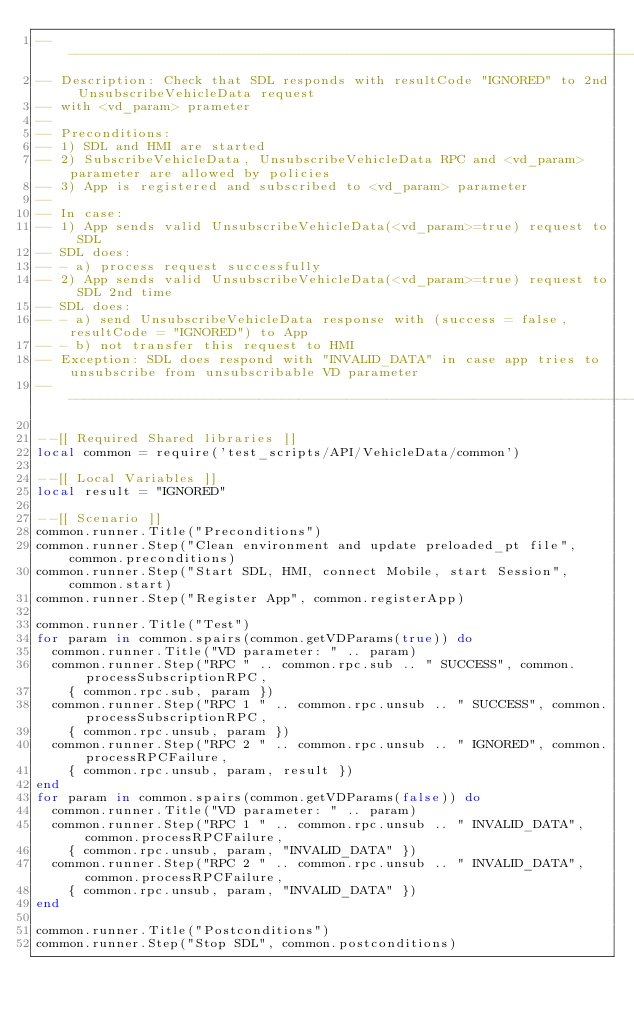Convert code to text. <code><loc_0><loc_0><loc_500><loc_500><_Lua_>---------------------------------------------------------------------------------------------------
-- Description: Check that SDL responds with resultCode "IGNORED" to 2nd UnsubscribeVehicleData request
-- with <vd_param> prameter
--
-- Preconditions:
-- 1) SDL and HMI are started
-- 2) SubscribeVehicleData, UnsubscribeVehicleData RPC and <vd_param> parameter are allowed by policies
-- 3) App is registered and subscribed to <vd_param> parameter
--
-- In case:
-- 1) App sends valid UnsubscribeVehicleData(<vd_param>=true) request to SDL
-- SDL does:
-- - a) process request successfully
-- 2) App sends valid UnsubscribeVehicleData(<vd_param>=true) request to SDL 2nd time
-- SDL does:
-- - a) send UnsubscribeVehicleData response with (success = false, resultCode = "IGNORED") to App
-- - b) not transfer this request to HMI
-- Exception: SDL does respond with "INVALID_DATA" in case app tries to unsubscribe from unsubscribable VD parameter
---------------------------------------------------------------------------------------------------

--[[ Required Shared libraries ]]
local common = require('test_scripts/API/VehicleData/common')

--[[ Local Variables ]]
local result = "IGNORED"

--[[ Scenario ]]
common.runner.Title("Preconditions")
common.runner.Step("Clean environment and update preloaded_pt file", common.preconditions)
common.runner.Step("Start SDL, HMI, connect Mobile, start Session", common.start)
common.runner.Step("Register App", common.registerApp)

common.runner.Title("Test")
for param in common.spairs(common.getVDParams(true)) do
  common.runner.Title("VD parameter: " .. param)
  common.runner.Step("RPC " .. common.rpc.sub .. " SUCCESS", common.processSubscriptionRPC,
    { common.rpc.sub, param })
  common.runner.Step("RPC 1 " .. common.rpc.unsub .. " SUCCESS", common.processSubscriptionRPC,
    { common.rpc.unsub, param })
  common.runner.Step("RPC 2 " .. common.rpc.unsub .. " IGNORED", common.processRPCFailure,
    { common.rpc.unsub, param, result })
end
for param in common.spairs(common.getVDParams(false)) do
  common.runner.Title("VD parameter: " .. param)
  common.runner.Step("RPC 1 " .. common.rpc.unsub .. " INVALID_DATA", common.processRPCFailure,
    { common.rpc.unsub, param, "INVALID_DATA" })
  common.runner.Step("RPC 2 " .. common.rpc.unsub .. " INVALID_DATA", common.processRPCFailure,
    { common.rpc.unsub, param, "INVALID_DATA" })
end

common.runner.Title("Postconditions")
common.runner.Step("Stop SDL", common.postconditions)
</code> 